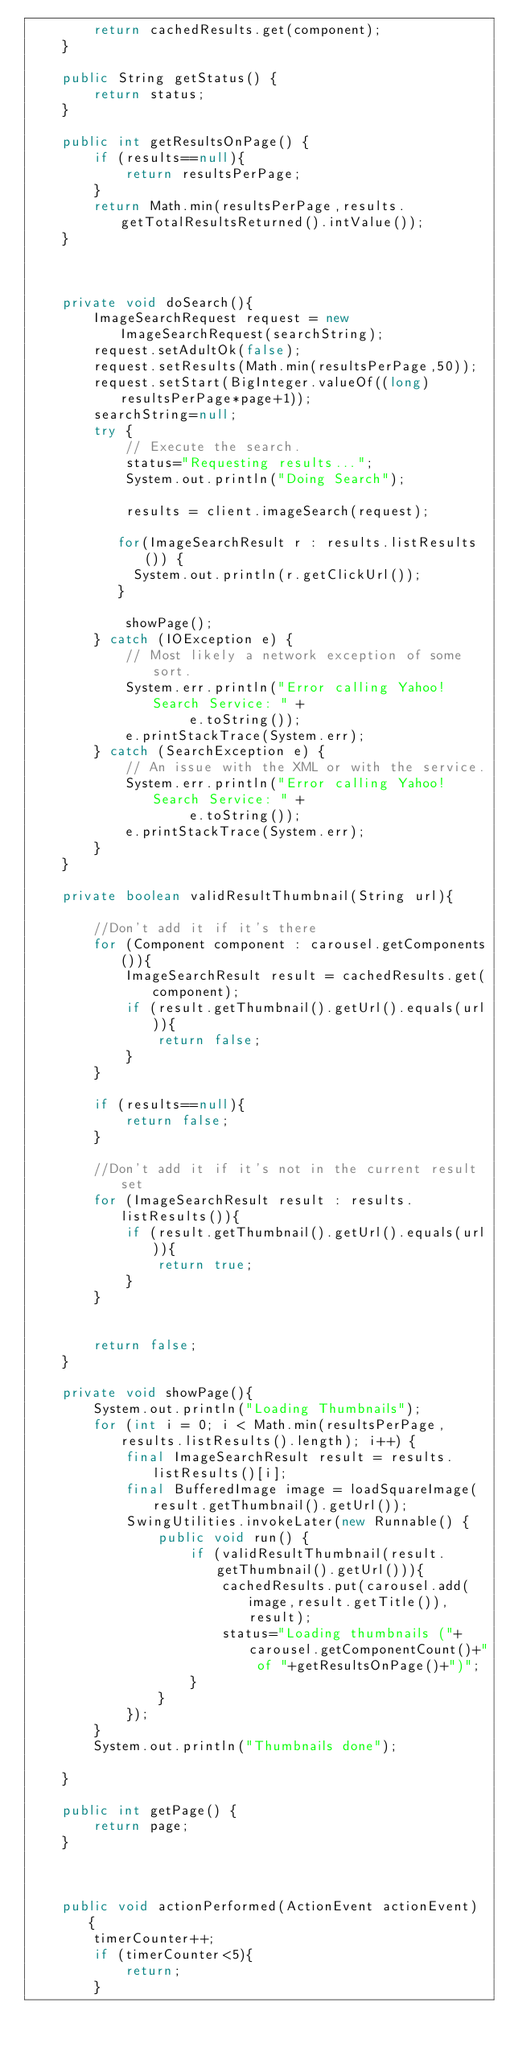<code> <loc_0><loc_0><loc_500><loc_500><_Java_>        return cachedResults.get(component);
    }

    public String getStatus() {
        return status;
    }

    public int getResultsOnPage() {
        if (results==null){
            return resultsPerPage;
        }
        return Math.min(resultsPerPage,results.getTotalResultsReturned().intValue());
    }
    

    
    private void doSearch(){
        ImageSearchRequest request = new ImageSearchRequest(searchString);            
        request.setAdultOk(false);
        request.setResults(Math.min(resultsPerPage,50));
        request.setStart(BigInteger.valueOf((long) resultsPerPage*page+1));
        searchString=null;
        try {
            // Execute the search.
            status="Requesting results...";
            System.out.println("Doing Search");

            results = client.imageSearch(request);
            
           for(ImageSearchResult r : results.listResults()) {
        	   System.out.println(r.getClickUrl());
           }
            
            showPage();
        } catch (IOException e) {
            // Most likely a network exception of some sort.
            System.err.println("Error calling Yahoo! Search Service: " +
                    e.toString());
            e.printStackTrace(System.err);
        } catch (SearchException e) {
            // An issue with the XML or with the service.
            System.err.println("Error calling Yahoo! Search Service: " +
                    e.toString());
            e.printStackTrace(System.err);
        }        
    }
        
    private boolean validResultThumbnail(String url){
        
        //Don't add it if it's there
        for (Component component : carousel.getComponents()){
            ImageSearchResult result = cachedResults.get(component);
            if (result.getThumbnail().getUrl().equals(url)){
                return false;
            }
        }
        
        if (results==null){
            return false;
        }
        
        //Don't add it if it's not in the current result set
        for (ImageSearchResult result : results.listResults()){
            if (result.getThumbnail().getUrl().equals(url)){
                return true;
            }
        }
        
        
        return false;
    }
    
    private void showPage(){
        System.out.println("Loading Thumbnails");
        for (int i = 0; i < Math.min(resultsPerPage,results.listResults().length); i++) {
            final ImageSearchResult result = results.listResults()[i];
            final BufferedImage image = loadSquareImage(result.getThumbnail().getUrl());
            SwingUtilities.invokeLater(new Runnable() {
                public void run() {
                    if (validResultThumbnail(result.getThumbnail().getUrl())){
                        cachedResults.put(carousel.add(image,result.getTitle()),result);
                        status="Loading thumbnails ("+carousel.getComponentCount()+" of "+getResultsOnPage()+")";
                    }
                }
            });
        }
        System.out.println("Thumbnails done");
        
    }

    public int getPage() {
        return page;
    }
    

    
    public void actionPerformed(ActionEvent actionEvent) {
        timerCounter++;
        if (timerCounter<5){
            return;
        }</code> 